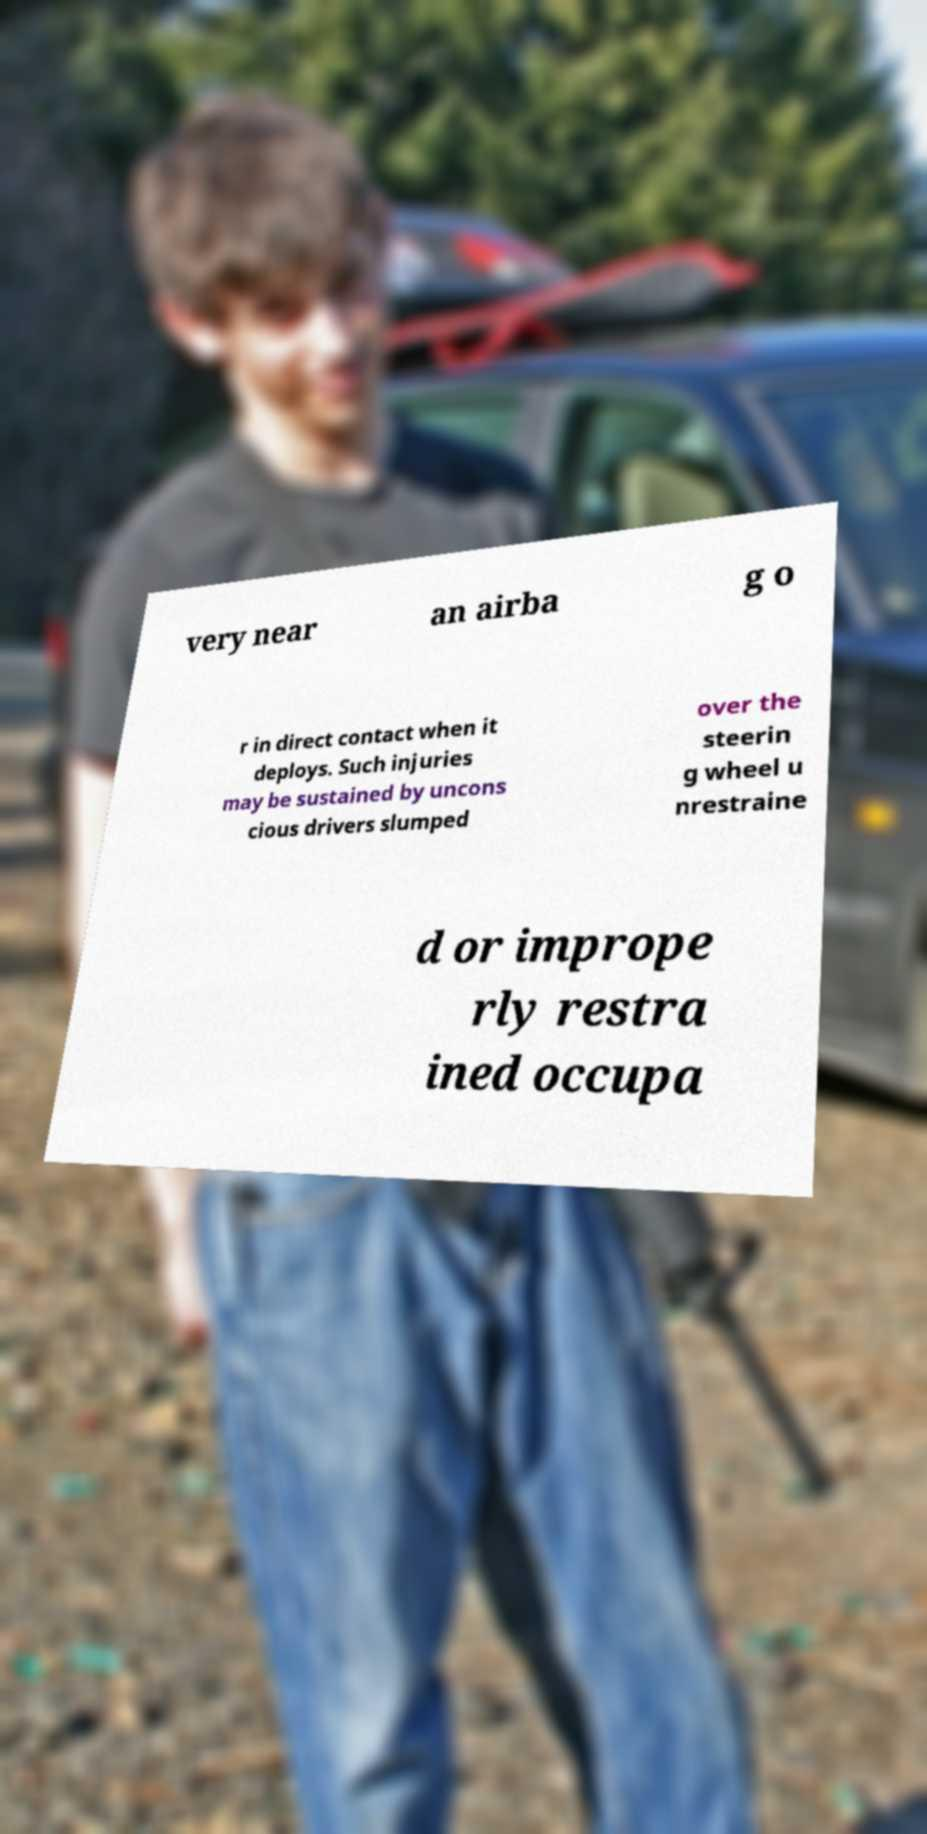Can you read and provide the text displayed in the image?This photo seems to have some interesting text. Can you extract and type it out for me? very near an airba g o r in direct contact when it deploys. Such injuries may be sustained by uncons cious drivers slumped over the steerin g wheel u nrestraine d or imprope rly restra ined occupa 